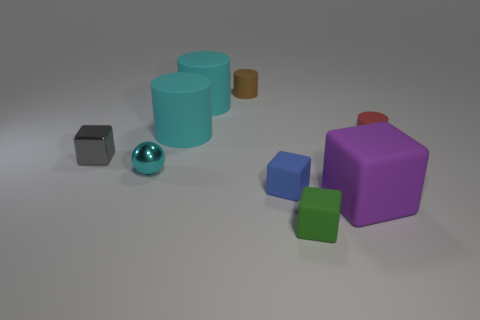Subtract all small gray shiny blocks. How many blocks are left? 3 Subtract all gray cubes. How many cyan cylinders are left? 2 Subtract all cyan cylinders. How many cylinders are left? 2 Subtract 1 cubes. How many cubes are left? 3 Subtract all cylinders. How many objects are left? 5 Subtract all purple cylinders. Subtract all cyan spheres. How many cylinders are left? 4 Subtract all large cylinders. Subtract all purple blocks. How many objects are left? 6 Add 8 small red things. How many small red things are left? 9 Add 4 tiny cylinders. How many tiny cylinders exist? 6 Subtract 0 brown balls. How many objects are left? 9 